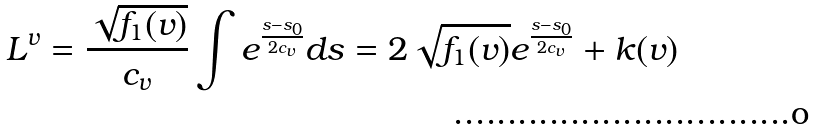Convert formula to latex. <formula><loc_0><loc_0><loc_500><loc_500>L ^ { v } = \frac { \sqrt { f _ { 1 } ( v ) } } { c _ { v } } \int { e ^ { \frac { s - s _ { 0 } } { 2 c _ { v } } } d s } = 2 \sqrt { f _ { 1 } ( v ) } e ^ { \frac { s - s _ { 0 } } { 2 c _ { v } } } + k ( v )</formula> 